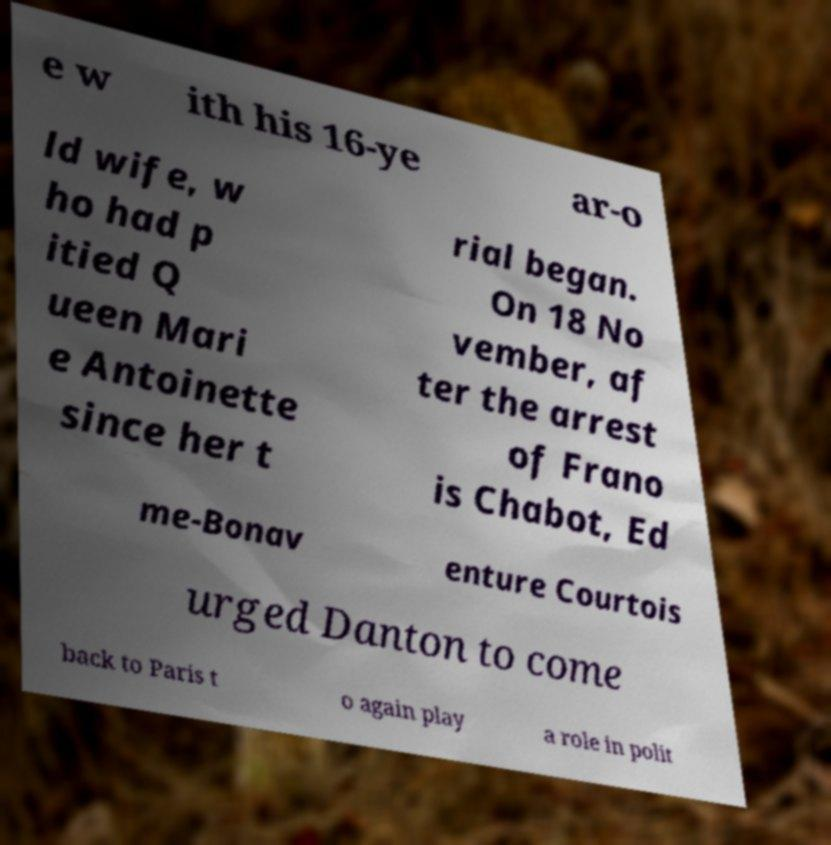Please read and relay the text visible in this image. What does it say? e w ith his 16-ye ar-o ld wife, w ho had p itied Q ueen Mari e Antoinette since her t rial began. On 18 No vember, af ter the arrest of Frano is Chabot, Ed me-Bonav enture Courtois urged Danton to come back to Paris t o again play a role in polit 